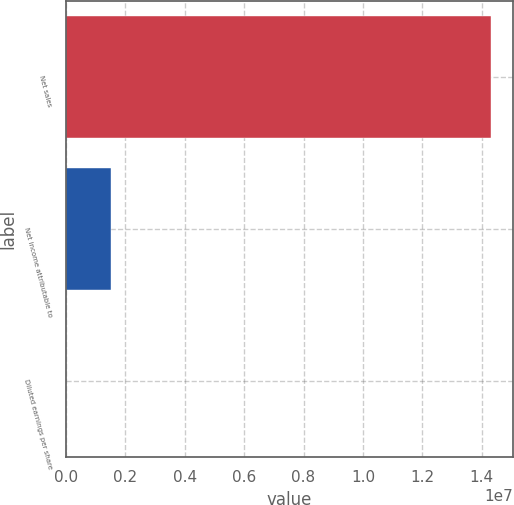Convert chart. <chart><loc_0><loc_0><loc_500><loc_500><bar_chart><fcel>Net sales<fcel>Net income attributable to<fcel>Diluted earnings per share<nl><fcel>1.43203e+07<fcel>1.51236e+06<fcel>11.48<nl></chart> 